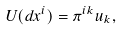<formula> <loc_0><loc_0><loc_500><loc_500>U ( d x ^ { i } ) = \pi ^ { i k } u _ { k } ,</formula> 